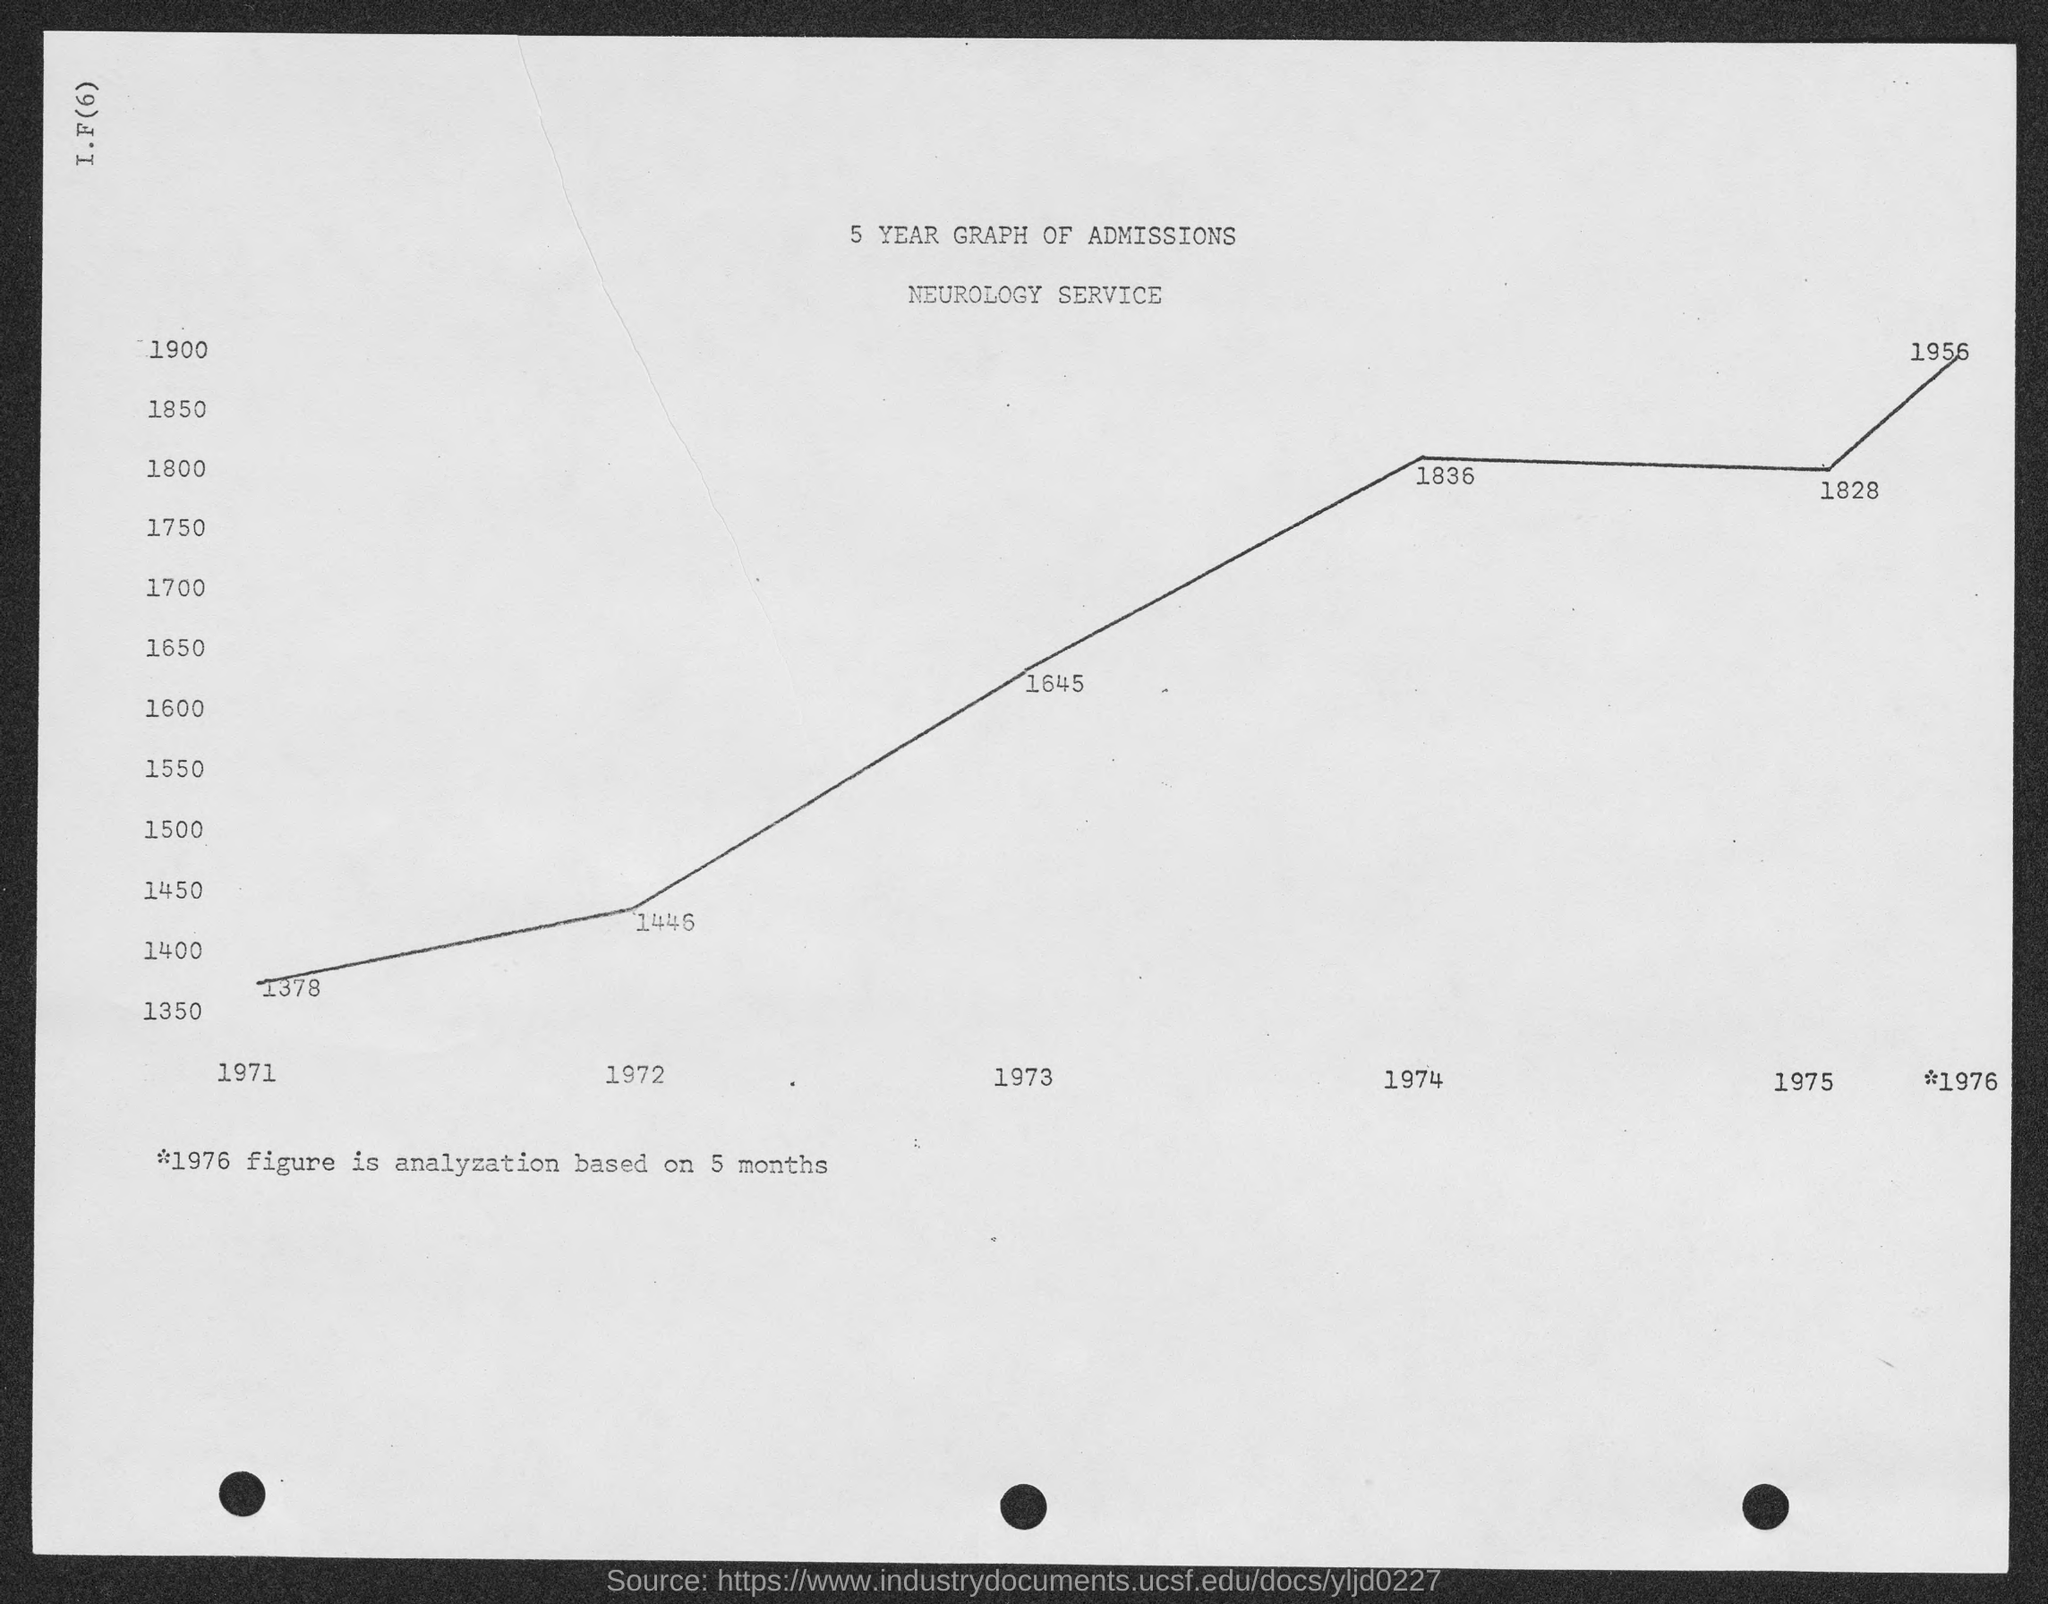Highlight a few significant elements in this photo. In the year 1974, the number of admissions was 1836, as shown by the graph. The number of admissions in 1972, as shown in the graph, was 1446. In the year 1975, the number of admissions was 1828, as shown in the graph. The number of admissions in the year 1971, as shown in the graph, was 1378. The number of admissions in the year 1973, as shown in the graph, was 1645. 